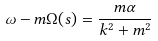Convert formula to latex. <formula><loc_0><loc_0><loc_500><loc_500>\omega - m \Omega ( s ) = \frac { m \alpha } { k ^ { 2 } + m ^ { 2 } }</formula> 